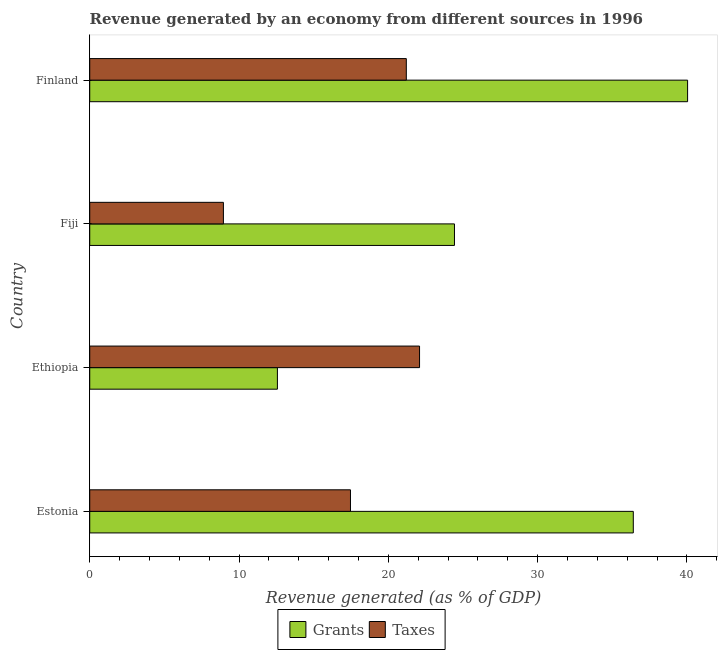How many groups of bars are there?
Give a very brief answer. 4. Are the number of bars per tick equal to the number of legend labels?
Give a very brief answer. Yes. How many bars are there on the 4th tick from the top?
Your answer should be very brief. 2. How many bars are there on the 1st tick from the bottom?
Ensure brevity in your answer.  2. What is the label of the 3rd group of bars from the top?
Your answer should be compact. Ethiopia. In how many cases, is the number of bars for a given country not equal to the number of legend labels?
Offer a very short reply. 0. What is the revenue generated by grants in Ethiopia?
Ensure brevity in your answer.  12.57. Across all countries, what is the maximum revenue generated by taxes?
Ensure brevity in your answer.  22.09. Across all countries, what is the minimum revenue generated by grants?
Give a very brief answer. 12.57. In which country was the revenue generated by grants minimum?
Offer a terse response. Ethiopia. What is the total revenue generated by grants in the graph?
Your answer should be compact. 113.44. What is the difference between the revenue generated by taxes in Fiji and that in Finland?
Make the answer very short. -12.25. What is the difference between the revenue generated by grants in Ethiopia and the revenue generated by taxes in Finland?
Ensure brevity in your answer.  -8.63. What is the average revenue generated by taxes per country?
Offer a terse response. 17.43. What is the difference between the revenue generated by taxes and revenue generated by grants in Fiji?
Your answer should be very brief. -15.47. What is the ratio of the revenue generated by grants in Ethiopia to that in Fiji?
Make the answer very short. 0.52. Is the revenue generated by grants in Estonia less than that in Finland?
Your answer should be very brief. Yes. Is the difference between the revenue generated by taxes in Ethiopia and Finland greater than the difference between the revenue generated by grants in Ethiopia and Finland?
Provide a succinct answer. Yes. What is the difference between the highest and the second highest revenue generated by taxes?
Your response must be concise. 0.89. What is the difference between the highest and the lowest revenue generated by taxes?
Your response must be concise. 13.14. In how many countries, is the revenue generated by grants greater than the average revenue generated by grants taken over all countries?
Your response must be concise. 2. What does the 1st bar from the top in Finland represents?
Make the answer very short. Taxes. What does the 1st bar from the bottom in Fiji represents?
Offer a very short reply. Grants. How many bars are there?
Your answer should be compact. 8. What is the difference between two consecutive major ticks on the X-axis?
Keep it short and to the point. 10. Does the graph contain any zero values?
Provide a short and direct response. No. Where does the legend appear in the graph?
Keep it short and to the point. Bottom center. How many legend labels are there?
Offer a terse response. 2. What is the title of the graph?
Keep it short and to the point. Revenue generated by an economy from different sources in 1996. Does "Constant 2005 US$" appear as one of the legend labels in the graph?
Provide a short and direct response. No. What is the label or title of the X-axis?
Offer a terse response. Revenue generated (as % of GDP). What is the Revenue generated (as % of GDP) of Grants in Estonia?
Your answer should be very brief. 36.4. What is the Revenue generated (as % of GDP) of Taxes in Estonia?
Offer a terse response. 17.46. What is the Revenue generated (as % of GDP) of Grants in Ethiopia?
Your answer should be very brief. 12.57. What is the Revenue generated (as % of GDP) in Taxes in Ethiopia?
Make the answer very short. 22.09. What is the Revenue generated (as % of GDP) of Grants in Fiji?
Keep it short and to the point. 24.43. What is the Revenue generated (as % of GDP) in Taxes in Fiji?
Your answer should be very brief. 8.95. What is the Revenue generated (as % of GDP) in Grants in Finland?
Provide a succinct answer. 40.04. What is the Revenue generated (as % of GDP) of Taxes in Finland?
Offer a terse response. 21.2. Across all countries, what is the maximum Revenue generated (as % of GDP) of Grants?
Provide a succinct answer. 40.04. Across all countries, what is the maximum Revenue generated (as % of GDP) in Taxes?
Make the answer very short. 22.09. Across all countries, what is the minimum Revenue generated (as % of GDP) in Grants?
Offer a very short reply. 12.57. Across all countries, what is the minimum Revenue generated (as % of GDP) in Taxes?
Offer a terse response. 8.95. What is the total Revenue generated (as % of GDP) of Grants in the graph?
Offer a terse response. 113.44. What is the total Revenue generated (as % of GDP) of Taxes in the graph?
Ensure brevity in your answer.  69.71. What is the difference between the Revenue generated (as % of GDP) in Grants in Estonia and that in Ethiopia?
Ensure brevity in your answer.  23.84. What is the difference between the Revenue generated (as % of GDP) in Taxes in Estonia and that in Ethiopia?
Offer a terse response. -4.63. What is the difference between the Revenue generated (as % of GDP) in Grants in Estonia and that in Fiji?
Offer a terse response. 11.98. What is the difference between the Revenue generated (as % of GDP) in Taxes in Estonia and that in Fiji?
Keep it short and to the point. 8.51. What is the difference between the Revenue generated (as % of GDP) of Grants in Estonia and that in Finland?
Make the answer very short. -3.64. What is the difference between the Revenue generated (as % of GDP) of Taxes in Estonia and that in Finland?
Your response must be concise. -3.74. What is the difference between the Revenue generated (as % of GDP) of Grants in Ethiopia and that in Fiji?
Ensure brevity in your answer.  -11.86. What is the difference between the Revenue generated (as % of GDP) in Taxes in Ethiopia and that in Fiji?
Make the answer very short. 13.14. What is the difference between the Revenue generated (as % of GDP) in Grants in Ethiopia and that in Finland?
Offer a very short reply. -27.47. What is the difference between the Revenue generated (as % of GDP) in Taxes in Ethiopia and that in Finland?
Ensure brevity in your answer.  0.89. What is the difference between the Revenue generated (as % of GDP) of Grants in Fiji and that in Finland?
Keep it short and to the point. -15.61. What is the difference between the Revenue generated (as % of GDP) in Taxes in Fiji and that in Finland?
Ensure brevity in your answer.  -12.25. What is the difference between the Revenue generated (as % of GDP) of Grants in Estonia and the Revenue generated (as % of GDP) of Taxes in Ethiopia?
Your answer should be very brief. 14.32. What is the difference between the Revenue generated (as % of GDP) in Grants in Estonia and the Revenue generated (as % of GDP) in Taxes in Fiji?
Ensure brevity in your answer.  27.45. What is the difference between the Revenue generated (as % of GDP) of Grants in Estonia and the Revenue generated (as % of GDP) of Taxes in Finland?
Your response must be concise. 15.2. What is the difference between the Revenue generated (as % of GDP) of Grants in Ethiopia and the Revenue generated (as % of GDP) of Taxes in Fiji?
Your answer should be compact. 3.62. What is the difference between the Revenue generated (as % of GDP) in Grants in Ethiopia and the Revenue generated (as % of GDP) in Taxes in Finland?
Give a very brief answer. -8.63. What is the difference between the Revenue generated (as % of GDP) of Grants in Fiji and the Revenue generated (as % of GDP) of Taxes in Finland?
Offer a terse response. 3.23. What is the average Revenue generated (as % of GDP) of Grants per country?
Ensure brevity in your answer.  28.36. What is the average Revenue generated (as % of GDP) in Taxes per country?
Offer a terse response. 17.43. What is the difference between the Revenue generated (as % of GDP) in Grants and Revenue generated (as % of GDP) in Taxes in Estonia?
Offer a very short reply. 18.94. What is the difference between the Revenue generated (as % of GDP) of Grants and Revenue generated (as % of GDP) of Taxes in Ethiopia?
Your response must be concise. -9.52. What is the difference between the Revenue generated (as % of GDP) of Grants and Revenue generated (as % of GDP) of Taxes in Fiji?
Keep it short and to the point. 15.47. What is the difference between the Revenue generated (as % of GDP) of Grants and Revenue generated (as % of GDP) of Taxes in Finland?
Your response must be concise. 18.84. What is the ratio of the Revenue generated (as % of GDP) in Grants in Estonia to that in Ethiopia?
Your answer should be compact. 2.9. What is the ratio of the Revenue generated (as % of GDP) of Taxes in Estonia to that in Ethiopia?
Give a very brief answer. 0.79. What is the ratio of the Revenue generated (as % of GDP) in Grants in Estonia to that in Fiji?
Your answer should be compact. 1.49. What is the ratio of the Revenue generated (as % of GDP) of Taxes in Estonia to that in Fiji?
Your answer should be very brief. 1.95. What is the ratio of the Revenue generated (as % of GDP) of Grants in Estonia to that in Finland?
Offer a terse response. 0.91. What is the ratio of the Revenue generated (as % of GDP) of Taxes in Estonia to that in Finland?
Your answer should be compact. 0.82. What is the ratio of the Revenue generated (as % of GDP) in Grants in Ethiopia to that in Fiji?
Your answer should be very brief. 0.51. What is the ratio of the Revenue generated (as % of GDP) in Taxes in Ethiopia to that in Fiji?
Offer a very short reply. 2.47. What is the ratio of the Revenue generated (as % of GDP) in Grants in Ethiopia to that in Finland?
Keep it short and to the point. 0.31. What is the ratio of the Revenue generated (as % of GDP) in Taxes in Ethiopia to that in Finland?
Provide a short and direct response. 1.04. What is the ratio of the Revenue generated (as % of GDP) of Grants in Fiji to that in Finland?
Offer a very short reply. 0.61. What is the ratio of the Revenue generated (as % of GDP) in Taxes in Fiji to that in Finland?
Provide a succinct answer. 0.42. What is the difference between the highest and the second highest Revenue generated (as % of GDP) of Grants?
Provide a succinct answer. 3.64. What is the difference between the highest and the second highest Revenue generated (as % of GDP) in Taxes?
Make the answer very short. 0.89. What is the difference between the highest and the lowest Revenue generated (as % of GDP) in Grants?
Offer a terse response. 27.47. What is the difference between the highest and the lowest Revenue generated (as % of GDP) of Taxes?
Keep it short and to the point. 13.14. 